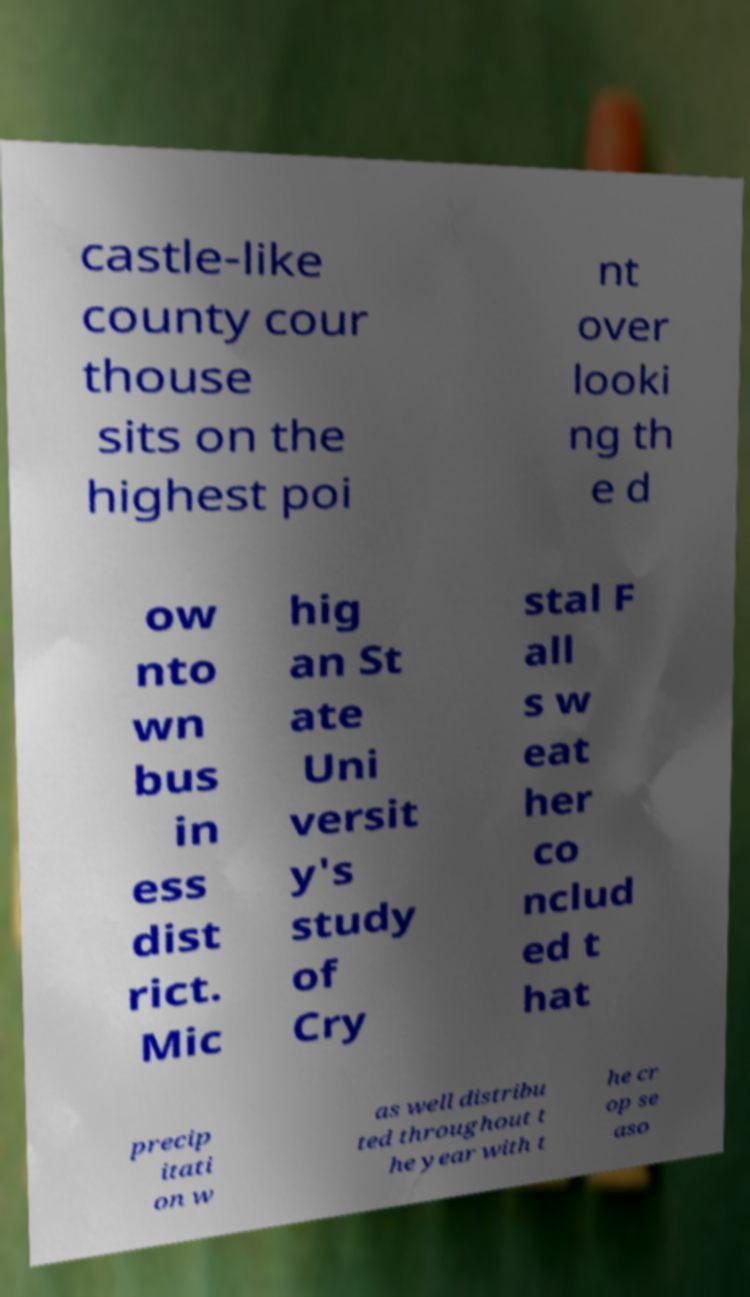There's text embedded in this image that I need extracted. Can you transcribe it verbatim? castle-like county cour thouse sits on the highest poi nt over looki ng th e d ow nto wn bus in ess dist rict. Mic hig an St ate Uni versit y's study of Cry stal F all s w eat her co nclud ed t hat precip itati on w as well distribu ted throughout t he year with t he cr op se aso 